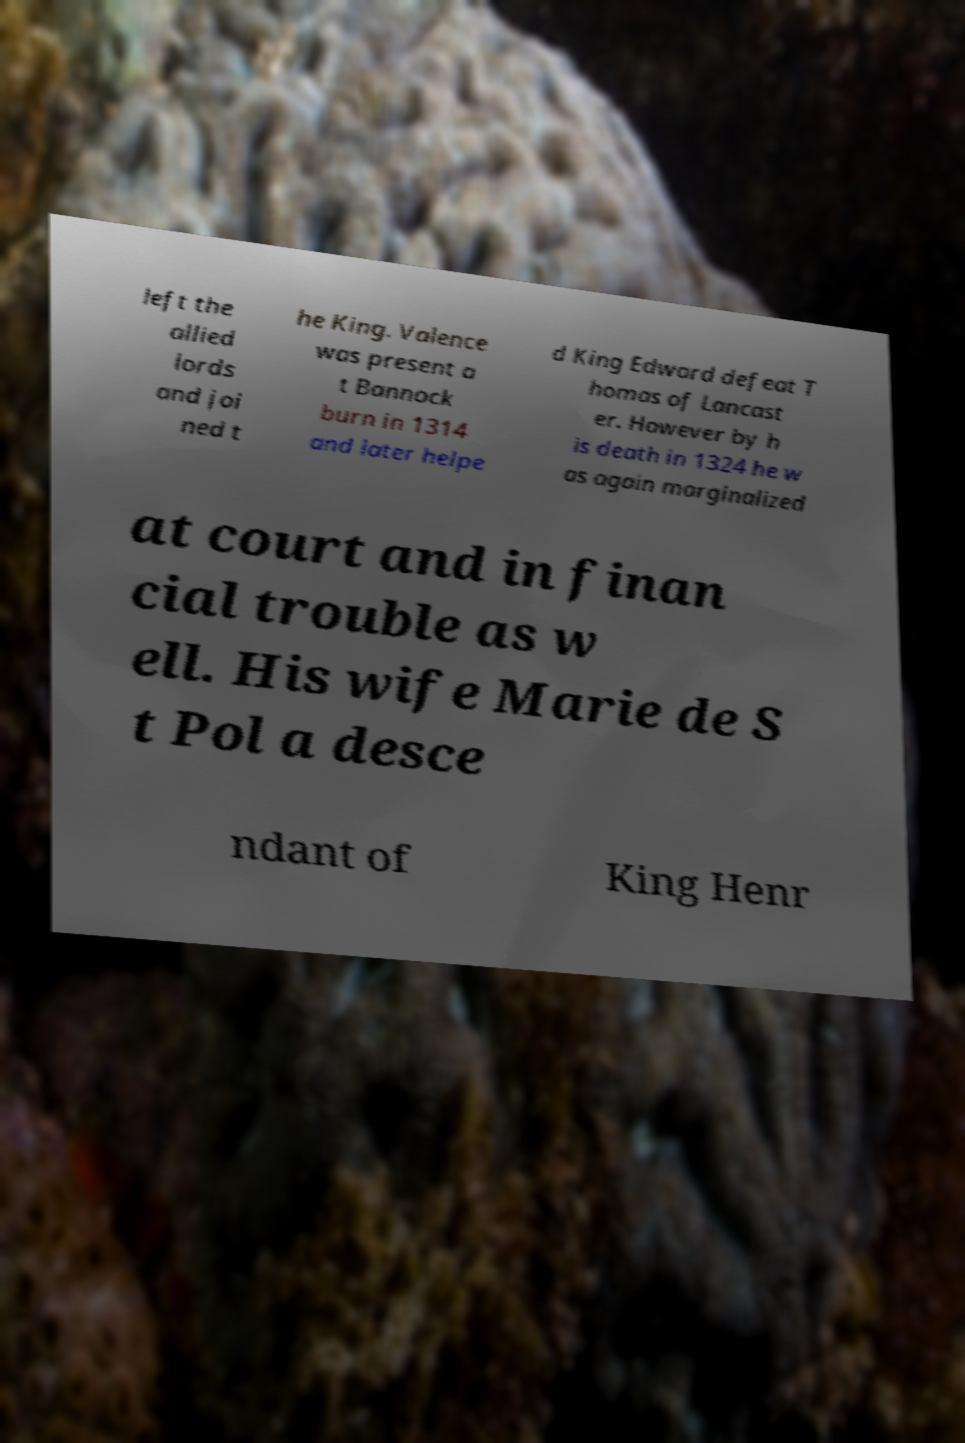Please read and relay the text visible in this image. What does it say? left the allied lords and joi ned t he King. Valence was present a t Bannock burn in 1314 and later helpe d King Edward defeat T homas of Lancast er. However by h is death in 1324 he w as again marginalized at court and in finan cial trouble as w ell. His wife Marie de S t Pol a desce ndant of King Henr 